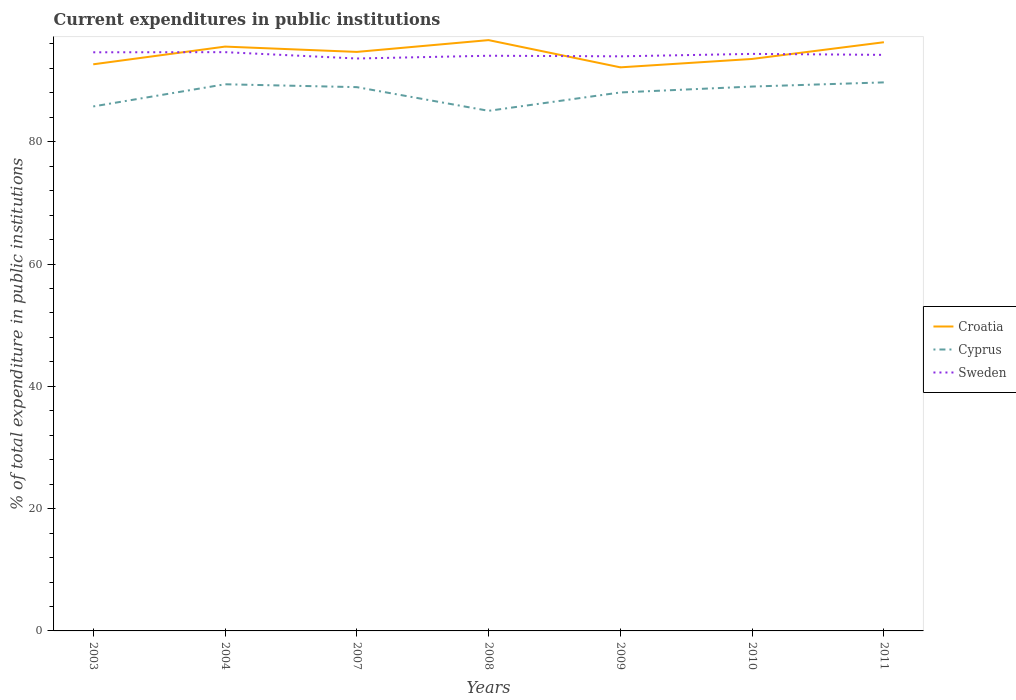How many different coloured lines are there?
Provide a succinct answer. 3. Across all years, what is the maximum current expenditures in public institutions in Cyprus?
Make the answer very short. 85.07. In which year was the current expenditures in public institutions in Cyprus maximum?
Give a very brief answer. 2008. What is the total current expenditures in public institutions in Croatia in the graph?
Your answer should be very brief. -1.93. What is the difference between the highest and the second highest current expenditures in public institutions in Sweden?
Offer a very short reply. 1.04. What is the difference between the highest and the lowest current expenditures in public institutions in Croatia?
Provide a short and direct response. 4. Is the current expenditures in public institutions in Cyprus strictly greater than the current expenditures in public institutions in Sweden over the years?
Your response must be concise. Yes. How many lines are there?
Your response must be concise. 3. Are the values on the major ticks of Y-axis written in scientific E-notation?
Keep it short and to the point. No. Where does the legend appear in the graph?
Give a very brief answer. Center right. What is the title of the graph?
Your answer should be very brief. Current expenditures in public institutions. What is the label or title of the Y-axis?
Ensure brevity in your answer.  % of total expenditure in public institutions. What is the % of total expenditure in public institutions in Croatia in 2003?
Give a very brief answer. 92.68. What is the % of total expenditure in public institutions in Cyprus in 2003?
Ensure brevity in your answer.  85.78. What is the % of total expenditure in public institutions in Sweden in 2003?
Provide a succinct answer. 94.64. What is the % of total expenditure in public institutions in Croatia in 2004?
Make the answer very short. 95.57. What is the % of total expenditure in public institutions in Cyprus in 2004?
Provide a short and direct response. 89.41. What is the % of total expenditure in public institutions of Sweden in 2004?
Provide a succinct answer. 94.66. What is the % of total expenditure in public institutions of Croatia in 2007?
Keep it short and to the point. 94.7. What is the % of total expenditure in public institutions of Cyprus in 2007?
Your answer should be very brief. 88.94. What is the % of total expenditure in public institutions in Sweden in 2007?
Offer a very short reply. 93.62. What is the % of total expenditure in public institutions of Croatia in 2008?
Your response must be concise. 96.63. What is the % of total expenditure in public institutions of Cyprus in 2008?
Offer a terse response. 85.07. What is the % of total expenditure in public institutions of Sweden in 2008?
Offer a very short reply. 94.08. What is the % of total expenditure in public institutions of Croatia in 2009?
Keep it short and to the point. 92.18. What is the % of total expenditure in public institutions in Cyprus in 2009?
Make the answer very short. 88.07. What is the % of total expenditure in public institutions of Sweden in 2009?
Provide a succinct answer. 93.98. What is the % of total expenditure in public institutions in Croatia in 2010?
Your response must be concise. 93.55. What is the % of total expenditure in public institutions in Cyprus in 2010?
Ensure brevity in your answer.  89.04. What is the % of total expenditure in public institutions in Sweden in 2010?
Your answer should be compact. 94.38. What is the % of total expenditure in public institutions of Croatia in 2011?
Give a very brief answer. 96.29. What is the % of total expenditure in public institutions of Cyprus in 2011?
Your response must be concise. 89.72. What is the % of total expenditure in public institutions of Sweden in 2011?
Give a very brief answer. 94.22. Across all years, what is the maximum % of total expenditure in public institutions in Croatia?
Keep it short and to the point. 96.63. Across all years, what is the maximum % of total expenditure in public institutions in Cyprus?
Offer a very short reply. 89.72. Across all years, what is the maximum % of total expenditure in public institutions of Sweden?
Give a very brief answer. 94.66. Across all years, what is the minimum % of total expenditure in public institutions of Croatia?
Keep it short and to the point. 92.18. Across all years, what is the minimum % of total expenditure in public institutions in Cyprus?
Your answer should be very brief. 85.07. Across all years, what is the minimum % of total expenditure in public institutions of Sweden?
Make the answer very short. 93.62. What is the total % of total expenditure in public institutions in Croatia in the graph?
Provide a short and direct response. 661.6. What is the total % of total expenditure in public institutions of Cyprus in the graph?
Offer a very short reply. 616.03. What is the total % of total expenditure in public institutions of Sweden in the graph?
Offer a terse response. 659.58. What is the difference between the % of total expenditure in public institutions of Croatia in 2003 and that in 2004?
Provide a short and direct response. -2.89. What is the difference between the % of total expenditure in public institutions in Cyprus in 2003 and that in 2004?
Provide a short and direct response. -3.63. What is the difference between the % of total expenditure in public institutions of Sweden in 2003 and that in 2004?
Ensure brevity in your answer.  -0.02. What is the difference between the % of total expenditure in public institutions of Croatia in 2003 and that in 2007?
Keep it short and to the point. -2.03. What is the difference between the % of total expenditure in public institutions of Cyprus in 2003 and that in 2007?
Provide a short and direct response. -3.16. What is the difference between the % of total expenditure in public institutions in Sweden in 2003 and that in 2007?
Your answer should be very brief. 1.02. What is the difference between the % of total expenditure in public institutions of Croatia in 2003 and that in 2008?
Ensure brevity in your answer.  -3.96. What is the difference between the % of total expenditure in public institutions in Cyprus in 2003 and that in 2008?
Make the answer very short. 0.72. What is the difference between the % of total expenditure in public institutions in Sweden in 2003 and that in 2008?
Offer a very short reply. 0.56. What is the difference between the % of total expenditure in public institutions in Croatia in 2003 and that in 2009?
Provide a short and direct response. 0.5. What is the difference between the % of total expenditure in public institutions of Cyprus in 2003 and that in 2009?
Provide a short and direct response. -2.29. What is the difference between the % of total expenditure in public institutions of Sweden in 2003 and that in 2009?
Provide a short and direct response. 0.66. What is the difference between the % of total expenditure in public institutions of Croatia in 2003 and that in 2010?
Make the answer very short. -0.87. What is the difference between the % of total expenditure in public institutions of Cyprus in 2003 and that in 2010?
Your answer should be very brief. -3.25. What is the difference between the % of total expenditure in public institutions in Sweden in 2003 and that in 2010?
Your response must be concise. 0.26. What is the difference between the % of total expenditure in public institutions of Croatia in 2003 and that in 2011?
Your answer should be compact. -3.61. What is the difference between the % of total expenditure in public institutions of Cyprus in 2003 and that in 2011?
Keep it short and to the point. -3.93. What is the difference between the % of total expenditure in public institutions in Sweden in 2003 and that in 2011?
Give a very brief answer. 0.42. What is the difference between the % of total expenditure in public institutions in Croatia in 2004 and that in 2007?
Provide a succinct answer. 0.87. What is the difference between the % of total expenditure in public institutions in Cyprus in 2004 and that in 2007?
Provide a succinct answer. 0.47. What is the difference between the % of total expenditure in public institutions in Sweden in 2004 and that in 2007?
Your answer should be compact. 1.04. What is the difference between the % of total expenditure in public institutions of Croatia in 2004 and that in 2008?
Provide a short and direct response. -1.06. What is the difference between the % of total expenditure in public institutions of Cyprus in 2004 and that in 2008?
Make the answer very short. 4.34. What is the difference between the % of total expenditure in public institutions of Sweden in 2004 and that in 2008?
Your answer should be compact. 0.59. What is the difference between the % of total expenditure in public institutions of Croatia in 2004 and that in 2009?
Give a very brief answer. 3.39. What is the difference between the % of total expenditure in public institutions of Cyprus in 2004 and that in 2009?
Provide a succinct answer. 1.34. What is the difference between the % of total expenditure in public institutions of Sweden in 2004 and that in 2009?
Your answer should be compact. 0.68. What is the difference between the % of total expenditure in public institutions in Croatia in 2004 and that in 2010?
Give a very brief answer. 2.02. What is the difference between the % of total expenditure in public institutions in Cyprus in 2004 and that in 2010?
Your answer should be compact. 0.37. What is the difference between the % of total expenditure in public institutions of Sweden in 2004 and that in 2010?
Your answer should be compact. 0.28. What is the difference between the % of total expenditure in public institutions of Croatia in 2004 and that in 2011?
Ensure brevity in your answer.  -0.71. What is the difference between the % of total expenditure in public institutions of Cyprus in 2004 and that in 2011?
Provide a succinct answer. -0.31. What is the difference between the % of total expenditure in public institutions in Sweden in 2004 and that in 2011?
Provide a short and direct response. 0.44. What is the difference between the % of total expenditure in public institutions of Croatia in 2007 and that in 2008?
Offer a terse response. -1.93. What is the difference between the % of total expenditure in public institutions in Cyprus in 2007 and that in 2008?
Keep it short and to the point. 3.87. What is the difference between the % of total expenditure in public institutions of Sweden in 2007 and that in 2008?
Make the answer very short. -0.45. What is the difference between the % of total expenditure in public institutions of Croatia in 2007 and that in 2009?
Your answer should be very brief. 2.53. What is the difference between the % of total expenditure in public institutions in Cyprus in 2007 and that in 2009?
Provide a short and direct response. 0.87. What is the difference between the % of total expenditure in public institutions of Sweden in 2007 and that in 2009?
Offer a very short reply. -0.36. What is the difference between the % of total expenditure in public institutions of Croatia in 2007 and that in 2010?
Make the answer very short. 1.15. What is the difference between the % of total expenditure in public institutions in Cyprus in 2007 and that in 2010?
Offer a terse response. -0.1. What is the difference between the % of total expenditure in public institutions in Sweden in 2007 and that in 2010?
Make the answer very short. -0.76. What is the difference between the % of total expenditure in public institutions in Croatia in 2007 and that in 2011?
Your response must be concise. -1.58. What is the difference between the % of total expenditure in public institutions of Cyprus in 2007 and that in 2011?
Give a very brief answer. -0.78. What is the difference between the % of total expenditure in public institutions of Sweden in 2007 and that in 2011?
Your answer should be compact. -0.59. What is the difference between the % of total expenditure in public institutions in Croatia in 2008 and that in 2009?
Your answer should be compact. 4.45. What is the difference between the % of total expenditure in public institutions in Cyprus in 2008 and that in 2009?
Provide a succinct answer. -3. What is the difference between the % of total expenditure in public institutions of Sweden in 2008 and that in 2009?
Your answer should be compact. 0.1. What is the difference between the % of total expenditure in public institutions of Croatia in 2008 and that in 2010?
Ensure brevity in your answer.  3.08. What is the difference between the % of total expenditure in public institutions of Cyprus in 2008 and that in 2010?
Give a very brief answer. -3.97. What is the difference between the % of total expenditure in public institutions in Sweden in 2008 and that in 2010?
Provide a succinct answer. -0.3. What is the difference between the % of total expenditure in public institutions of Croatia in 2008 and that in 2011?
Provide a short and direct response. 0.35. What is the difference between the % of total expenditure in public institutions in Cyprus in 2008 and that in 2011?
Make the answer very short. -4.65. What is the difference between the % of total expenditure in public institutions of Sweden in 2008 and that in 2011?
Give a very brief answer. -0.14. What is the difference between the % of total expenditure in public institutions in Croatia in 2009 and that in 2010?
Offer a very short reply. -1.37. What is the difference between the % of total expenditure in public institutions of Cyprus in 2009 and that in 2010?
Give a very brief answer. -0.97. What is the difference between the % of total expenditure in public institutions in Sweden in 2009 and that in 2010?
Offer a very short reply. -0.4. What is the difference between the % of total expenditure in public institutions of Croatia in 2009 and that in 2011?
Your answer should be very brief. -4.11. What is the difference between the % of total expenditure in public institutions in Cyprus in 2009 and that in 2011?
Offer a very short reply. -1.65. What is the difference between the % of total expenditure in public institutions in Sweden in 2009 and that in 2011?
Offer a very short reply. -0.24. What is the difference between the % of total expenditure in public institutions of Croatia in 2010 and that in 2011?
Make the answer very short. -2.73. What is the difference between the % of total expenditure in public institutions of Cyprus in 2010 and that in 2011?
Your answer should be compact. -0.68. What is the difference between the % of total expenditure in public institutions in Sweden in 2010 and that in 2011?
Your answer should be compact. 0.16. What is the difference between the % of total expenditure in public institutions in Croatia in 2003 and the % of total expenditure in public institutions in Cyprus in 2004?
Ensure brevity in your answer.  3.27. What is the difference between the % of total expenditure in public institutions of Croatia in 2003 and the % of total expenditure in public institutions of Sweden in 2004?
Give a very brief answer. -1.99. What is the difference between the % of total expenditure in public institutions of Cyprus in 2003 and the % of total expenditure in public institutions of Sweden in 2004?
Provide a succinct answer. -8.88. What is the difference between the % of total expenditure in public institutions in Croatia in 2003 and the % of total expenditure in public institutions in Cyprus in 2007?
Give a very brief answer. 3.74. What is the difference between the % of total expenditure in public institutions of Croatia in 2003 and the % of total expenditure in public institutions of Sweden in 2007?
Your response must be concise. -0.95. What is the difference between the % of total expenditure in public institutions of Cyprus in 2003 and the % of total expenditure in public institutions of Sweden in 2007?
Provide a succinct answer. -7.84. What is the difference between the % of total expenditure in public institutions in Croatia in 2003 and the % of total expenditure in public institutions in Cyprus in 2008?
Your response must be concise. 7.61. What is the difference between the % of total expenditure in public institutions in Croatia in 2003 and the % of total expenditure in public institutions in Sweden in 2008?
Your answer should be compact. -1.4. What is the difference between the % of total expenditure in public institutions in Cyprus in 2003 and the % of total expenditure in public institutions in Sweden in 2008?
Keep it short and to the point. -8.29. What is the difference between the % of total expenditure in public institutions in Croatia in 2003 and the % of total expenditure in public institutions in Cyprus in 2009?
Your response must be concise. 4.61. What is the difference between the % of total expenditure in public institutions in Croatia in 2003 and the % of total expenditure in public institutions in Sweden in 2009?
Provide a succinct answer. -1.3. What is the difference between the % of total expenditure in public institutions in Cyprus in 2003 and the % of total expenditure in public institutions in Sweden in 2009?
Offer a terse response. -8.2. What is the difference between the % of total expenditure in public institutions of Croatia in 2003 and the % of total expenditure in public institutions of Cyprus in 2010?
Your answer should be compact. 3.64. What is the difference between the % of total expenditure in public institutions in Croatia in 2003 and the % of total expenditure in public institutions in Sweden in 2010?
Your answer should be compact. -1.7. What is the difference between the % of total expenditure in public institutions of Cyprus in 2003 and the % of total expenditure in public institutions of Sweden in 2010?
Your answer should be compact. -8.6. What is the difference between the % of total expenditure in public institutions in Croatia in 2003 and the % of total expenditure in public institutions in Cyprus in 2011?
Offer a very short reply. 2.96. What is the difference between the % of total expenditure in public institutions of Croatia in 2003 and the % of total expenditure in public institutions of Sweden in 2011?
Provide a short and direct response. -1.54. What is the difference between the % of total expenditure in public institutions in Cyprus in 2003 and the % of total expenditure in public institutions in Sweden in 2011?
Keep it short and to the point. -8.43. What is the difference between the % of total expenditure in public institutions of Croatia in 2004 and the % of total expenditure in public institutions of Cyprus in 2007?
Offer a terse response. 6.63. What is the difference between the % of total expenditure in public institutions in Croatia in 2004 and the % of total expenditure in public institutions in Sweden in 2007?
Keep it short and to the point. 1.95. What is the difference between the % of total expenditure in public institutions in Cyprus in 2004 and the % of total expenditure in public institutions in Sweden in 2007?
Keep it short and to the point. -4.21. What is the difference between the % of total expenditure in public institutions in Croatia in 2004 and the % of total expenditure in public institutions in Cyprus in 2008?
Provide a short and direct response. 10.5. What is the difference between the % of total expenditure in public institutions of Croatia in 2004 and the % of total expenditure in public institutions of Sweden in 2008?
Provide a succinct answer. 1.49. What is the difference between the % of total expenditure in public institutions of Cyprus in 2004 and the % of total expenditure in public institutions of Sweden in 2008?
Give a very brief answer. -4.67. What is the difference between the % of total expenditure in public institutions of Croatia in 2004 and the % of total expenditure in public institutions of Cyprus in 2009?
Your answer should be compact. 7.5. What is the difference between the % of total expenditure in public institutions of Croatia in 2004 and the % of total expenditure in public institutions of Sweden in 2009?
Offer a very short reply. 1.59. What is the difference between the % of total expenditure in public institutions of Cyprus in 2004 and the % of total expenditure in public institutions of Sweden in 2009?
Your response must be concise. -4.57. What is the difference between the % of total expenditure in public institutions in Croatia in 2004 and the % of total expenditure in public institutions in Cyprus in 2010?
Give a very brief answer. 6.53. What is the difference between the % of total expenditure in public institutions of Croatia in 2004 and the % of total expenditure in public institutions of Sweden in 2010?
Your response must be concise. 1.19. What is the difference between the % of total expenditure in public institutions of Cyprus in 2004 and the % of total expenditure in public institutions of Sweden in 2010?
Keep it short and to the point. -4.97. What is the difference between the % of total expenditure in public institutions of Croatia in 2004 and the % of total expenditure in public institutions of Cyprus in 2011?
Ensure brevity in your answer.  5.85. What is the difference between the % of total expenditure in public institutions of Croatia in 2004 and the % of total expenditure in public institutions of Sweden in 2011?
Provide a short and direct response. 1.35. What is the difference between the % of total expenditure in public institutions of Cyprus in 2004 and the % of total expenditure in public institutions of Sweden in 2011?
Give a very brief answer. -4.81. What is the difference between the % of total expenditure in public institutions of Croatia in 2007 and the % of total expenditure in public institutions of Cyprus in 2008?
Provide a short and direct response. 9.63. What is the difference between the % of total expenditure in public institutions of Croatia in 2007 and the % of total expenditure in public institutions of Sweden in 2008?
Keep it short and to the point. 0.63. What is the difference between the % of total expenditure in public institutions in Cyprus in 2007 and the % of total expenditure in public institutions in Sweden in 2008?
Give a very brief answer. -5.14. What is the difference between the % of total expenditure in public institutions in Croatia in 2007 and the % of total expenditure in public institutions in Cyprus in 2009?
Offer a terse response. 6.63. What is the difference between the % of total expenditure in public institutions in Croatia in 2007 and the % of total expenditure in public institutions in Sweden in 2009?
Offer a terse response. 0.72. What is the difference between the % of total expenditure in public institutions of Cyprus in 2007 and the % of total expenditure in public institutions of Sweden in 2009?
Provide a succinct answer. -5.04. What is the difference between the % of total expenditure in public institutions in Croatia in 2007 and the % of total expenditure in public institutions in Cyprus in 2010?
Your answer should be very brief. 5.67. What is the difference between the % of total expenditure in public institutions in Croatia in 2007 and the % of total expenditure in public institutions in Sweden in 2010?
Provide a short and direct response. 0.32. What is the difference between the % of total expenditure in public institutions in Cyprus in 2007 and the % of total expenditure in public institutions in Sweden in 2010?
Offer a very short reply. -5.44. What is the difference between the % of total expenditure in public institutions of Croatia in 2007 and the % of total expenditure in public institutions of Cyprus in 2011?
Make the answer very short. 4.99. What is the difference between the % of total expenditure in public institutions in Croatia in 2007 and the % of total expenditure in public institutions in Sweden in 2011?
Offer a very short reply. 0.49. What is the difference between the % of total expenditure in public institutions in Cyprus in 2007 and the % of total expenditure in public institutions in Sweden in 2011?
Provide a succinct answer. -5.28. What is the difference between the % of total expenditure in public institutions of Croatia in 2008 and the % of total expenditure in public institutions of Cyprus in 2009?
Provide a short and direct response. 8.56. What is the difference between the % of total expenditure in public institutions of Croatia in 2008 and the % of total expenditure in public institutions of Sweden in 2009?
Make the answer very short. 2.65. What is the difference between the % of total expenditure in public institutions in Cyprus in 2008 and the % of total expenditure in public institutions in Sweden in 2009?
Provide a succinct answer. -8.91. What is the difference between the % of total expenditure in public institutions of Croatia in 2008 and the % of total expenditure in public institutions of Cyprus in 2010?
Provide a succinct answer. 7.6. What is the difference between the % of total expenditure in public institutions in Croatia in 2008 and the % of total expenditure in public institutions in Sweden in 2010?
Ensure brevity in your answer.  2.25. What is the difference between the % of total expenditure in public institutions of Cyprus in 2008 and the % of total expenditure in public institutions of Sweden in 2010?
Give a very brief answer. -9.31. What is the difference between the % of total expenditure in public institutions of Croatia in 2008 and the % of total expenditure in public institutions of Cyprus in 2011?
Offer a very short reply. 6.91. What is the difference between the % of total expenditure in public institutions of Croatia in 2008 and the % of total expenditure in public institutions of Sweden in 2011?
Your answer should be compact. 2.41. What is the difference between the % of total expenditure in public institutions of Cyprus in 2008 and the % of total expenditure in public institutions of Sweden in 2011?
Give a very brief answer. -9.15. What is the difference between the % of total expenditure in public institutions of Croatia in 2009 and the % of total expenditure in public institutions of Cyprus in 2010?
Provide a short and direct response. 3.14. What is the difference between the % of total expenditure in public institutions of Croatia in 2009 and the % of total expenditure in public institutions of Sweden in 2010?
Ensure brevity in your answer.  -2.2. What is the difference between the % of total expenditure in public institutions of Cyprus in 2009 and the % of total expenditure in public institutions of Sweden in 2010?
Offer a terse response. -6.31. What is the difference between the % of total expenditure in public institutions in Croatia in 2009 and the % of total expenditure in public institutions in Cyprus in 2011?
Offer a very short reply. 2.46. What is the difference between the % of total expenditure in public institutions in Croatia in 2009 and the % of total expenditure in public institutions in Sweden in 2011?
Your answer should be very brief. -2.04. What is the difference between the % of total expenditure in public institutions of Cyprus in 2009 and the % of total expenditure in public institutions of Sweden in 2011?
Ensure brevity in your answer.  -6.15. What is the difference between the % of total expenditure in public institutions in Croatia in 2010 and the % of total expenditure in public institutions in Cyprus in 2011?
Your response must be concise. 3.83. What is the difference between the % of total expenditure in public institutions in Croatia in 2010 and the % of total expenditure in public institutions in Sweden in 2011?
Provide a succinct answer. -0.67. What is the difference between the % of total expenditure in public institutions of Cyprus in 2010 and the % of total expenditure in public institutions of Sweden in 2011?
Keep it short and to the point. -5.18. What is the average % of total expenditure in public institutions in Croatia per year?
Your response must be concise. 94.51. What is the average % of total expenditure in public institutions in Cyprus per year?
Your answer should be very brief. 88. What is the average % of total expenditure in public institutions of Sweden per year?
Your answer should be compact. 94.23. In the year 2003, what is the difference between the % of total expenditure in public institutions of Croatia and % of total expenditure in public institutions of Cyprus?
Keep it short and to the point. 6.89. In the year 2003, what is the difference between the % of total expenditure in public institutions in Croatia and % of total expenditure in public institutions in Sweden?
Provide a short and direct response. -1.96. In the year 2003, what is the difference between the % of total expenditure in public institutions in Cyprus and % of total expenditure in public institutions in Sweden?
Provide a succinct answer. -8.86. In the year 2004, what is the difference between the % of total expenditure in public institutions in Croatia and % of total expenditure in public institutions in Cyprus?
Provide a succinct answer. 6.16. In the year 2004, what is the difference between the % of total expenditure in public institutions of Croatia and % of total expenditure in public institutions of Sweden?
Make the answer very short. 0.91. In the year 2004, what is the difference between the % of total expenditure in public institutions of Cyprus and % of total expenditure in public institutions of Sweden?
Make the answer very short. -5.25. In the year 2007, what is the difference between the % of total expenditure in public institutions of Croatia and % of total expenditure in public institutions of Cyprus?
Offer a very short reply. 5.76. In the year 2007, what is the difference between the % of total expenditure in public institutions of Croatia and % of total expenditure in public institutions of Sweden?
Your response must be concise. 1.08. In the year 2007, what is the difference between the % of total expenditure in public institutions in Cyprus and % of total expenditure in public institutions in Sweden?
Provide a short and direct response. -4.68. In the year 2008, what is the difference between the % of total expenditure in public institutions in Croatia and % of total expenditure in public institutions in Cyprus?
Make the answer very short. 11.56. In the year 2008, what is the difference between the % of total expenditure in public institutions of Croatia and % of total expenditure in public institutions of Sweden?
Provide a short and direct response. 2.56. In the year 2008, what is the difference between the % of total expenditure in public institutions of Cyprus and % of total expenditure in public institutions of Sweden?
Your answer should be compact. -9.01. In the year 2009, what is the difference between the % of total expenditure in public institutions of Croatia and % of total expenditure in public institutions of Cyprus?
Make the answer very short. 4.11. In the year 2009, what is the difference between the % of total expenditure in public institutions of Croatia and % of total expenditure in public institutions of Sweden?
Provide a succinct answer. -1.8. In the year 2009, what is the difference between the % of total expenditure in public institutions of Cyprus and % of total expenditure in public institutions of Sweden?
Your answer should be very brief. -5.91. In the year 2010, what is the difference between the % of total expenditure in public institutions of Croatia and % of total expenditure in public institutions of Cyprus?
Give a very brief answer. 4.51. In the year 2010, what is the difference between the % of total expenditure in public institutions of Croatia and % of total expenditure in public institutions of Sweden?
Your answer should be compact. -0.83. In the year 2010, what is the difference between the % of total expenditure in public institutions in Cyprus and % of total expenditure in public institutions in Sweden?
Ensure brevity in your answer.  -5.34. In the year 2011, what is the difference between the % of total expenditure in public institutions in Croatia and % of total expenditure in public institutions in Cyprus?
Your answer should be compact. 6.57. In the year 2011, what is the difference between the % of total expenditure in public institutions in Croatia and % of total expenditure in public institutions in Sweden?
Offer a very short reply. 2.07. In the year 2011, what is the difference between the % of total expenditure in public institutions in Cyprus and % of total expenditure in public institutions in Sweden?
Offer a very short reply. -4.5. What is the ratio of the % of total expenditure in public institutions in Croatia in 2003 to that in 2004?
Your response must be concise. 0.97. What is the ratio of the % of total expenditure in public institutions in Cyprus in 2003 to that in 2004?
Ensure brevity in your answer.  0.96. What is the ratio of the % of total expenditure in public institutions in Sweden in 2003 to that in 2004?
Your response must be concise. 1. What is the ratio of the % of total expenditure in public institutions of Croatia in 2003 to that in 2007?
Your answer should be compact. 0.98. What is the ratio of the % of total expenditure in public institutions of Cyprus in 2003 to that in 2007?
Provide a succinct answer. 0.96. What is the ratio of the % of total expenditure in public institutions of Sweden in 2003 to that in 2007?
Your answer should be very brief. 1.01. What is the ratio of the % of total expenditure in public institutions of Croatia in 2003 to that in 2008?
Your response must be concise. 0.96. What is the ratio of the % of total expenditure in public institutions of Cyprus in 2003 to that in 2008?
Your answer should be very brief. 1.01. What is the ratio of the % of total expenditure in public institutions of Sweden in 2003 to that in 2008?
Offer a terse response. 1.01. What is the ratio of the % of total expenditure in public institutions in Croatia in 2003 to that in 2009?
Offer a terse response. 1.01. What is the ratio of the % of total expenditure in public institutions in Cyprus in 2003 to that in 2009?
Offer a terse response. 0.97. What is the ratio of the % of total expenditure in public institutions in Sweden in 2003 to that in 2009?
Ensure brevity in your answer.  1.01. What is the ratio of the % of total expenditure in public institutions in Croatia in 2003 to that in 2010?
Your answer should be compact. 0.99. What is the ratio of the % of total expenditure in public institutions in Cyprus in 2003 to that in 2010?
Provide a succinct answer. 0.96. What is the ratio of the % of total expenditure in public institutions of Croatia in 2003 to that in 2011?
Your answer should be very brief. 0.96. What is the ratio of the % of total expenditure in public institutions of Cyprus in 2003 to that in 2011?
Keep it short and to the point. 0.96. What is the ratio of the % of total expenditure in public institutions in Sweden in 2003 to that in 2011?
Offer a very short reply. 1. What is the ratio of the % of total expenditure in public institutions of Croatia in 2004 to that in 2007?
Provide a short and direct response. 1.01. What is the ratio of the % of total expenditure in public institutions in Sweden in 2004 to that in 2007?
Give a very brief answer. 1.01. What is the ratio of the % of total expenditure in public institutions in Cyprus in 2004 to that in 2008?
Offer a very short reply. 1.05. What is the ratio of the % of total expenditure in public institutions in Croatia in 2004 to that in 2009?
Make the answer very short. 1.04. What is the ratio of the % of total expenditure in public institutions in Cyprus in 2004 to that in 2009?
Give a very brief answer. 1.02. What is the ratio of the % of total expenditure in public institutions of Sweden in 2004 to that in 2009?
Your answer should be compact. 1.01. What is the ratio of the % of total expenditure in public institutions in Croatia in 2004 to that in 2010?
Provide a short and direct response. 1.02. What is the ratio of the % of total expenditure in public institutions of Sweden in 2004 to that in 2010?
Your response must be concise. 1. What is the ratio of the % of total expenditure in public institutions of Sweden in 2004 to that in 2011?
Offer a terse response. 1. What is the ratio of the % of total expenditure in public institutions in Cyprus in 2007 to that in 2008?
Your response must be concise. 1.05. What is the ratio of the % of total expenditure in public institutions in Sweden in 2007 to that in 2008?
Your answer should be compact. 1. What is the ratio of the % of total expenditure in public institutions in Croatia in 2007 to that in 2009?
Your response must be concise. 1.03. What is the ratio of the % of total expenditure in public institutions of Cyprus in 2007 to that in 2009?
Provide a succinct answer. 1.01. What is the ratio of the % of total expenditure in public institutions in Croatia in 2007 to that in 2010?
Your response must be concise. 1.01. What is the ratio of the % of total expenditure in public institutions in Sweden in 2007 to that in 2010?
Provide a succinct answer. 0.99. What is the ratio of the % of total expenditure in public institutions in Croatia in 2007 to that in 2011?
Offer a terse response. 0.98. What is the ratio of the % of total expenditure in public institutions of Cyprus in 2007 to that in 2011?
Give a very brief answer. 0.99. What is the ratio of the % of total expenditure in public institutions of Croatia in 2008 to that in 2009?
Your answer should be compact. 1.05. What is the ratio of the % of total expenditure in public institutions in Cyprus in 2008 to that in 2009?
Your answer should be compact. 0.97. What is the ratio of the % of total expenditure in public institutions of Croatia in 2008 to that in 2010?
Your response must be concise. 1.03. What is the ratio of the % of total expenditure in public institutions of Cyprus in 2008 to that in 2010?
Ensure brevity in your answer.  0.96. What is the ratio of the % of total expenditure in public institutions of Cyprus in 2008 to that in 2011?
Offer a very short reply. 0.95. What is the ratio of the % of total expenditure in public institutions in Sweden in 2008 to that in 2011?
Provide a succinct answer. 1. What is the ratio of the % of total expenditure in public institutions in Cyprus in 2009 to that in 2010?
Your answer should be very brief. 0.99. What is the ratio of the % of total expenditure in public institutions of Sweden in 2009 to that in 2010?
Your answer should be very brief. 1. What is the ratio of the % of total expenditure in public institutions in Croatia in 2009 to that in 2011?
Provide a succinct answer. 0.96. What is the ratio of the % of total expenditure in public institutions of Cyprus in 2009 to that in 2011?
Keep it short and to the point. 0.98. What is the ratio of the % of total expenditure in public institutions in Croatia in 2010 to that in 2011?
Ensure brevity in your answer.  0.97. What is the ratio of the % of total expenditure in public institutions of Sweden in 2010 to that in 2011?
Your response must be concise. 1. What is the difference between the highest and the second highest % of total expenditure in public institutions in Croatia?
Make the answer very short. 0.35. What is the difference between the highest and the second highest % of total expenditure in public institutions in Cyprus?
Give a very brief answer. 0.31. What is the difference between the highest and the second highest % of total expenditure in public institutions of Sweden?
Make the answer very short. 0.02. What is the difference between the highest and the lowest % of total expenditure in public institutions in Croatia?
Provide a succinct answer. 4.45. What is the difference between the highest and the lowest % of total expenditure in public institutions of Cyprus?
Offer a very short reply. 4.65. What is the difference between the highest and the lowest % of total expenditure in public institutions in Sweden?
Ensure brevity in your answer.  1.04. 